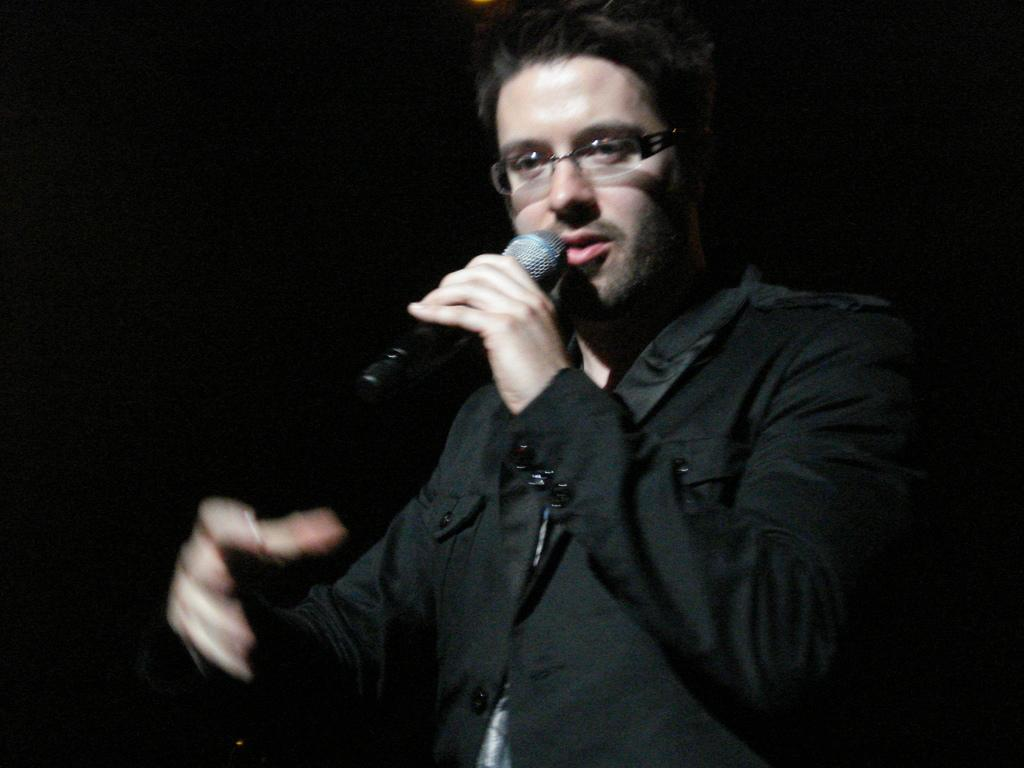What is the main subject of the image? There is a person in the image. What is the person wearing? The person is wearing a black-colored dress. What accessory is the person wearing? The person is wearing spectacles. What is the person's posture in the image? The person is standing. What object is the person holding in the image? The person is holding a microphone in his hand. What color is the background of the image? The background of the image is black. How many stars can be seen in the image? There are no stars visible in the image; the background is black. What type of picture is the person holding in the image? The person is holding a microphone, not a picture, in the image. 